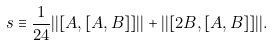<formula> <loc_0><loc_0><loc_500><loc_500>s \equiv \frac { 1 } { 2 4 } | | [ A , [ A , B ] ] | | + | | [ 2 B , [ A , B ] ] | | .</formula> 